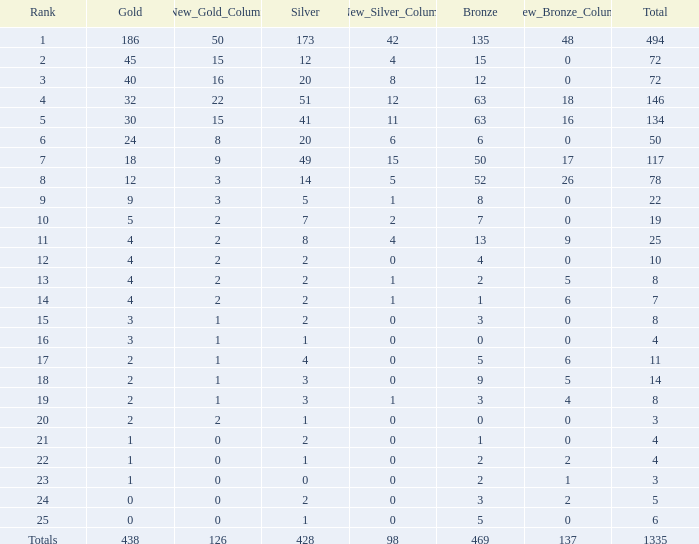Could you parse the entire table as a dict? {'header': ['Rank', 'Gold', 'New_Gold_Column', 'Silver', 'New_Silver_Column', 'Bronze', 'New_Bronze_Column', 'Total'], 'rows': [['1', '186', '50', '173', '42', '135', '48', '494'], ['2', '45', '15', '12', '4', '15', '0', '72'], ['3', '40', '16', '20', '8', '12', '0', '72'], ['4', '32', '22', '51', '12', '63', '18', '146'], ['5', '30', '15', '41', '11', '63', '16', '134'], ['6', '24', '8', '20', '6', '6', '0', '50'], ['7', '18', '9', '49', '15', '50', '17', '117'], ['8', '12', '3', '14', '5', '52', '26', '78'], ['9', '9', '3', '5', '1', '8', '0', '22'], ['10', '5', '2', '7', '2', '7', '0', '19'], ['11', '4', '2', '8', '4', '13', '9', '25'], ['12', '4', '2', '2', '0', '4', '0', '10'], ['13', '4', '2', '2', '1', '2', '5', '8'], ['14', '4', '2', '2', '1', '1', '6', '7'], ['15', '3', '1', '2', '0', '3', '0', '8'], ['16', '3', '1', '1', '0', '0', '0', '4'], ['17', '2', '1', '4', '0', '5', '6', '11'], ['18', '2', '1', '3', '0', '9', '5', '14'], ['19', '2', '1', '3', '1', '3', '4', '8'], ['20', '2', '2', '1', '0', '0', '0', '3'], ['21', '1', '0', '2', '0', '1', '0', '4'], ['22', '1', '0', '1', '0', '2', '2', '4'], ['23', '1', '0', '0', '0', '2', '1', '3'], ['24', '0', '0', '2', '0', '3', '2', '5'], ['25', '0', '0', '1', '0', '5', '0', '6'], ['Totals', '438', '126', '428', '98', '469', '137', '1335']]} What is the number of bronze medals when the total medals were 78 and there were less than 12 golds? None. 